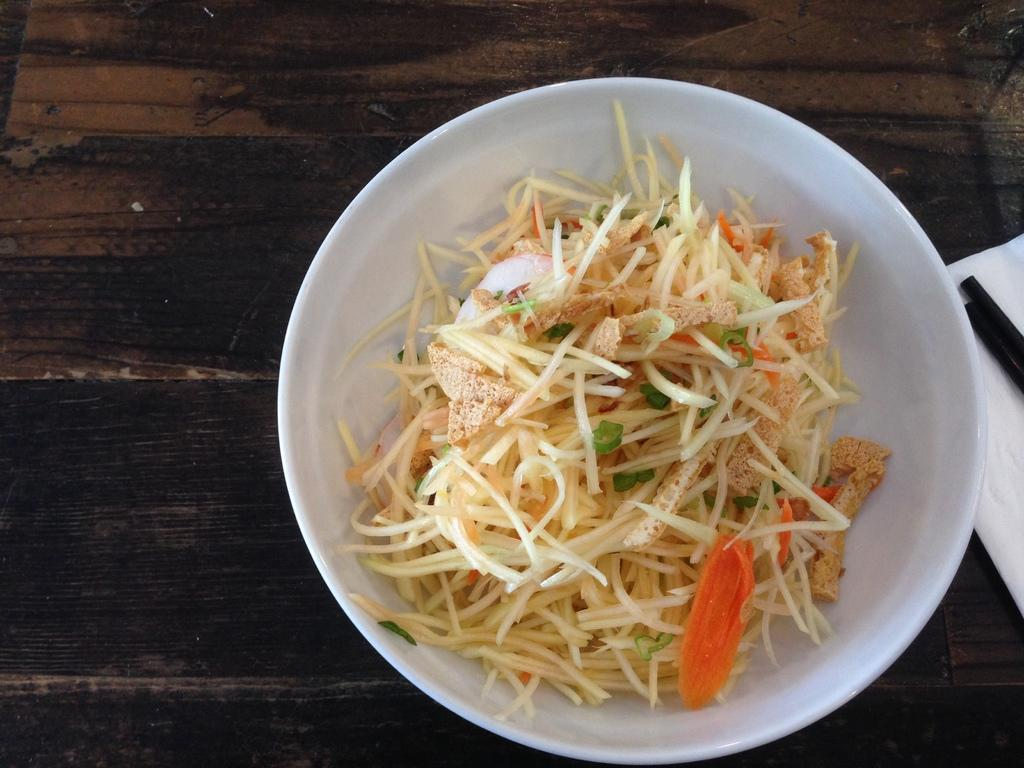What color is the bowl that is visible in the image? There is a white bowl in the image. What is inside the white bowl? There is food in the white bowl. What type of item can be used for cleaning or wiping in the image? There is a tissue paper in the image. What utensil is present in the image? There are chopsticks in the image. What type of prose is being written on the tissue paper in the image? There is no prose or writing present on the tissue paper in the image. 